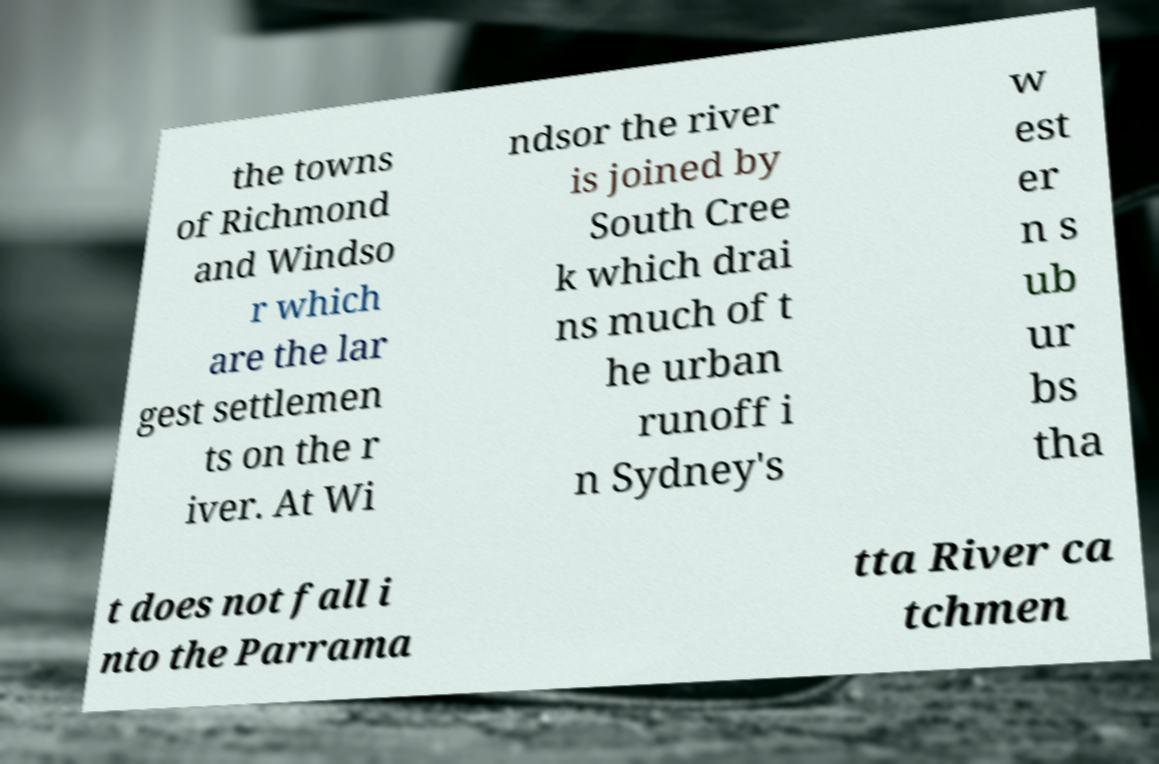What messages or text are displayed in this image? I need them in a readable, typed format. the towns of Richmond and Windso r which are the lar gest settlemen ts on the r iver. At Wi ndsor the river is joined by South Cree k which drai ns much of t he urban runoff i n Sydney's w est er n s ub ur bs tha t does not fall i nto the Parrama tta River ca tchmen 